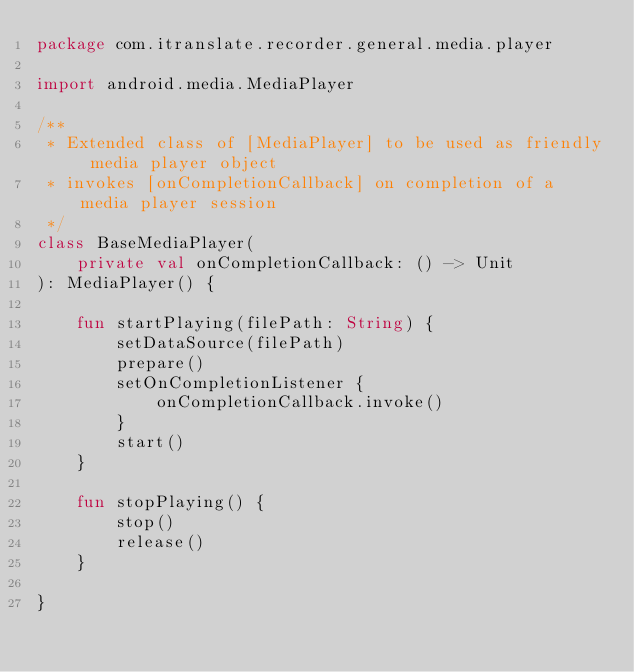Convert code to text. <code><loc_0><loc_0><loc_500><loc_500><_Kotlin_>package com.itranslate.recorder.general.media.player

import android.media.MediaPlayer

/**
 * Extended class of [MediaPlayer] to be used as friendly media player object
 * invokes [onCompletionCallback] on completion of a media player session
 */
class BaseMediaPlayer(
    private val onCompletionCallback: () -> Unit
): MediaPlayer() {

    fun startPlaying(filePath: String) {
        setDataSource(filePath)
        prepare()
        setOnCompletionListener {
            onCompletionCallback.invoke()
        }
        start()
    }

    fun stopPlaying() {
        stop()
        release()
    }

}</code> 